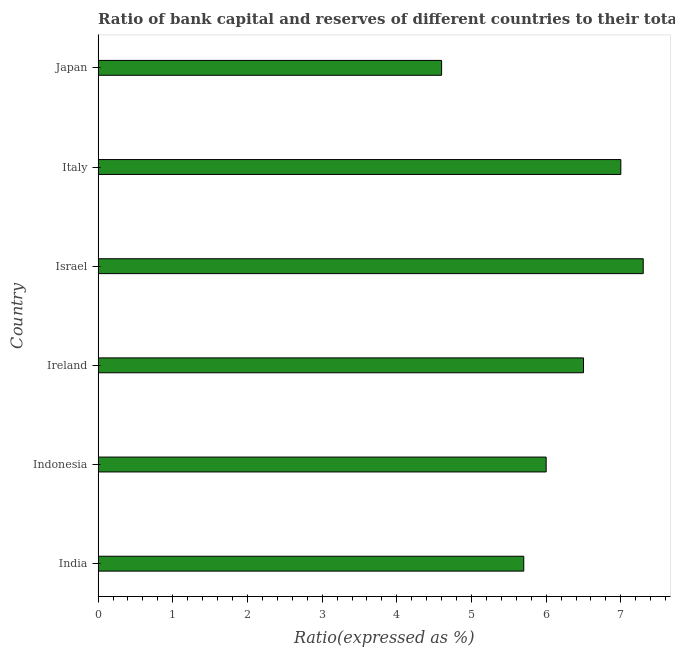Does the graph contain grids?
Provide a short and direct response. No. What is the title of the graph?
Ensure brevity in your answer.  Ratio of bank capital and reserves of different countries to their total assets in 2000. What is the label or title of the X-axis?
Your answer should be very brief. Ratio(expressed as %). What is the label or title of the Y-axis?
Make the answer very short. Country. Across all countries, what is the maximum bank capital to assets ratio?
Keep it short and to the point. 7.3. Across all countries, what is the minimum bank capital to assets ratio?
Provide a short and direct response. 4.6. What is the sum of the bank capital to assets ratio?
Make the answer very short. 37.1. What is the average bank capital to assets ratio per country?
Offer a terse response. 6.18. What is the median bank capital to assets ratio?
Offer a terse response. 6.25. In how many countries, is the bank capital to assets ratio greater than 1.4 %?
Your answer should be compact. 6. What is the ratio of the bank capital to assets ratio in Italy to that in Japan?
Offer a terse response. 1.52. Is the bank capital to assets ratio in India less than that in Israel?
Offer a terse response. Yes. Is the sum of the bank capital to assets ratio in India and Ireland greater than the maximum bank capital to assets ratio across all countries?
Your answer should be very brief. Yes. What is the difference between the highest and the lowest bank capital to assets ratio?
Make the answer very short. 2.7. In how many countries, is the bank capital to assets ratio greater than the average bank capital to assets ratio taken over all countries?
Offer a very short reply. 3. Are all the bars in the graph horizontal?
Keep it short and to the point. Yes. What is the difference between two consecutive major ticks on the X-axis?
Your answer should be very brief. 1. What is the Ratio(expressed as %) of Ireland?
Provide a succinct answer. 6.5. What is the difference between the Ratio(expressed as %) in India and Ireland?
Your response must be concise. -0.8. What is the difference between the Ratio(expressed as %) in India and Italy?
Your response must be concise. -1.3. What is the difference between the Ratio(expressed as %) in Indonesia and Ireland?
Your response must be concise. -0.5. What is the difference between the Ratio(expressed as %) in Indonesia and Japan?
Offer a terse response. 1.4. What is the difference between the Ratio(expressed as %) in Ireland and Italy?
Offer a terse response. -0.5. What is the difference between the Ratio(expressed as %) in Ireland and Japan?
Offer a very short reply. 1.9. What is the difference between the Ratio(expressed as %) in Italy and Japan?
Ensure brevity in your answer.  2.4. What is the ratio of the Ratio(expressed as %) in India to that in Ireland?
Offer a very short reply. 0.88. What is the ratio of the Ratio(expressed as %) in India to that in Israel?
Your answer should be compact. 0.78. What is the ratio of the Ratio(expressed as %) in India to that in Italy?
Your response must be concise. 0.81. What is the ratio of the Ratio(expressed as %) in India to that in Japan?
Your answer should be compact. 1.24. What is the ratio of the Ratio(expressed as %) in Indonesia to that in Ireland?
Your answer should be compact. 0.92. What is the ratio of the Ratio(expressed as %) in Indonesia to that in Israel?
Provide a succinct answer. 0.82. What is the ratio of the Ratio(expressed as %) in Indonesia to that in Italy?
Your response must be concise. 0.86. What is the ratio of the Ratio(expressed as %) in Indonesia to that in Japan?
Keep it short and to the point. 1.3. What is the ratio of the Ratio(expressed as %) in Ireland to that in Israel?
Your answer should be compact. 0.89. What is the ratio of the Ratio(expressed as %) in Ireland to that in Italy?
Provide a succinct answer. 0.93. What is the ratio of the Ratio(expressed as %) in Ireland to that in Japan?
Offer a very short reply. 1.41. What is the ratio of the Ratio(expressed as %) in Israel to that in Italy?
Provide a short and direct response. 1.04. What is the ratio of the Ratio(expressed as %) in Israel to that in Japan?
Your answer should be compact. 1.59. What is the ratio of the Ratio(expressed as %) in Italy to that in Japan?
Your answer should be very brief. 1.52. 